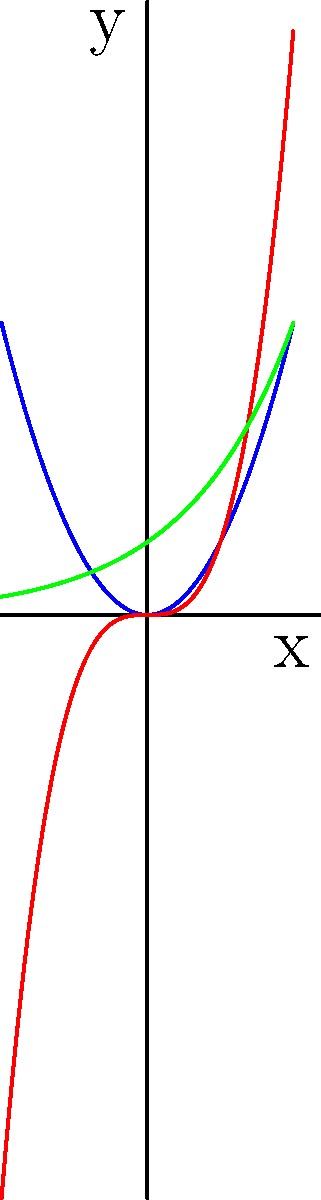Consider the three functions plotted above: $f(x) = x^2$, $g(x) = x^3$, and $h(x) = 2^x$. As $x$ approaches positive infinity, which function will have the highest growth rate? To determine which function has the highest growth rate as $x$ approaches positive infinity, we need to compare their asymptotic behavior:

1. For $f(x) = x^2$:
   This is a quadratic function, which grows relatively slowly.

2. For $g(x) = x^3$:
   This is a cubic function, which grows faster than $x^2$ for large $x$.

3. For $h(x) = 2^x$:
   This is an exponential function, which grows faster than any polynomial function for large $x$.

To compare these functions mathematically:

a) Compare $x^2$ and $x^3$:
   $\lim_{x \to \infty} \frac{x^3}{x^2} = \lim_{x \to \infty} x = \infty$
   This shows that $x^3$ grows faster than $x^2$.

b) Compare $2^x$ and $x^3$:
   $\lim_{x \to \infty} \frac{2^x}{x^3} = \infty$
   This can be proven using L'Hôpital's rule or by observing that exponential functions always outgrow polynomial functions.

Therefore, as $x$ approaches positive infinity, $h(x) = 2^x$ will have the highest growth rate among the three functions.
Answer: $h(x) = 2^x$ 